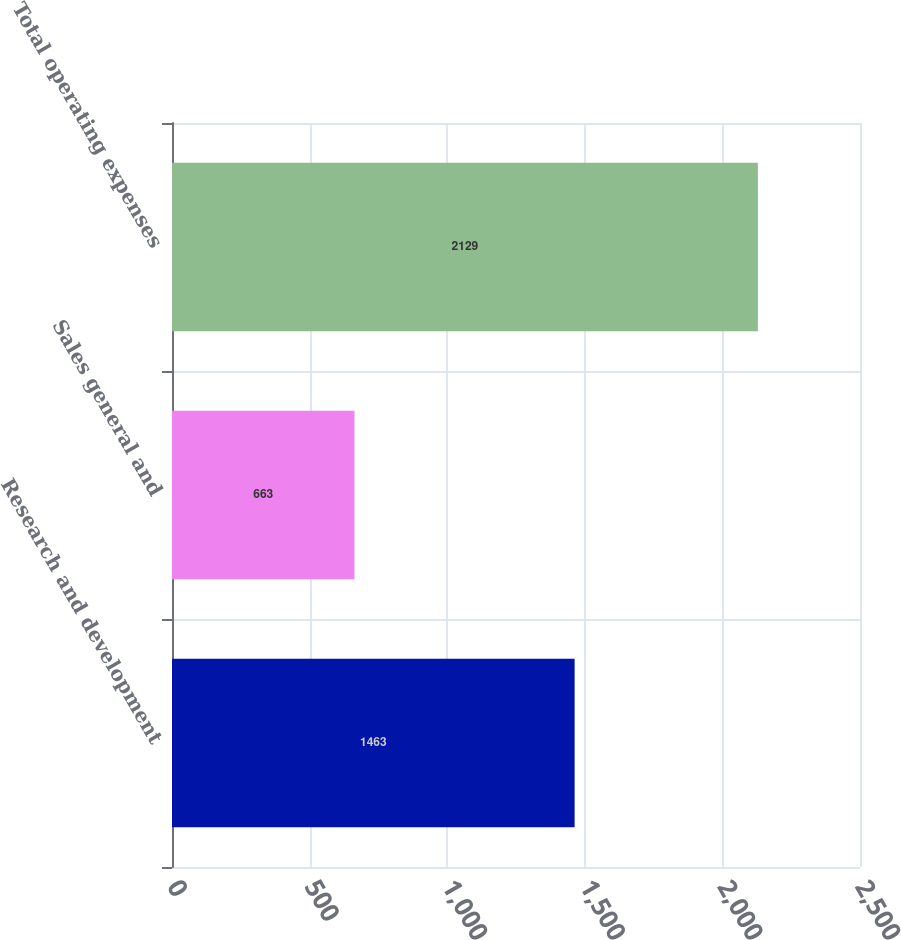Convert chart. <chart><loc_0><loc_0><loc_500><loc_500><bar_chart><fcel>Research and development<fcel>Sales general and<fcel>Total operating expenses<nl><fcel>1463<fcel>663<fcel>2129<nl></chart> 